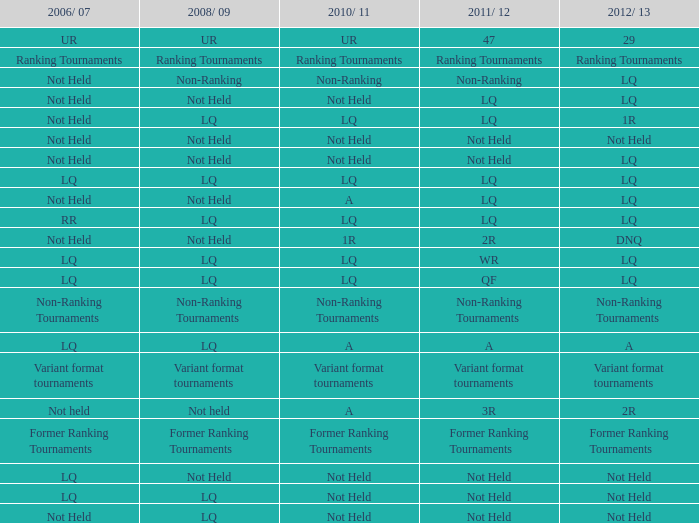What is 2010-11, when 2006/07 is considered as ur? UR. 